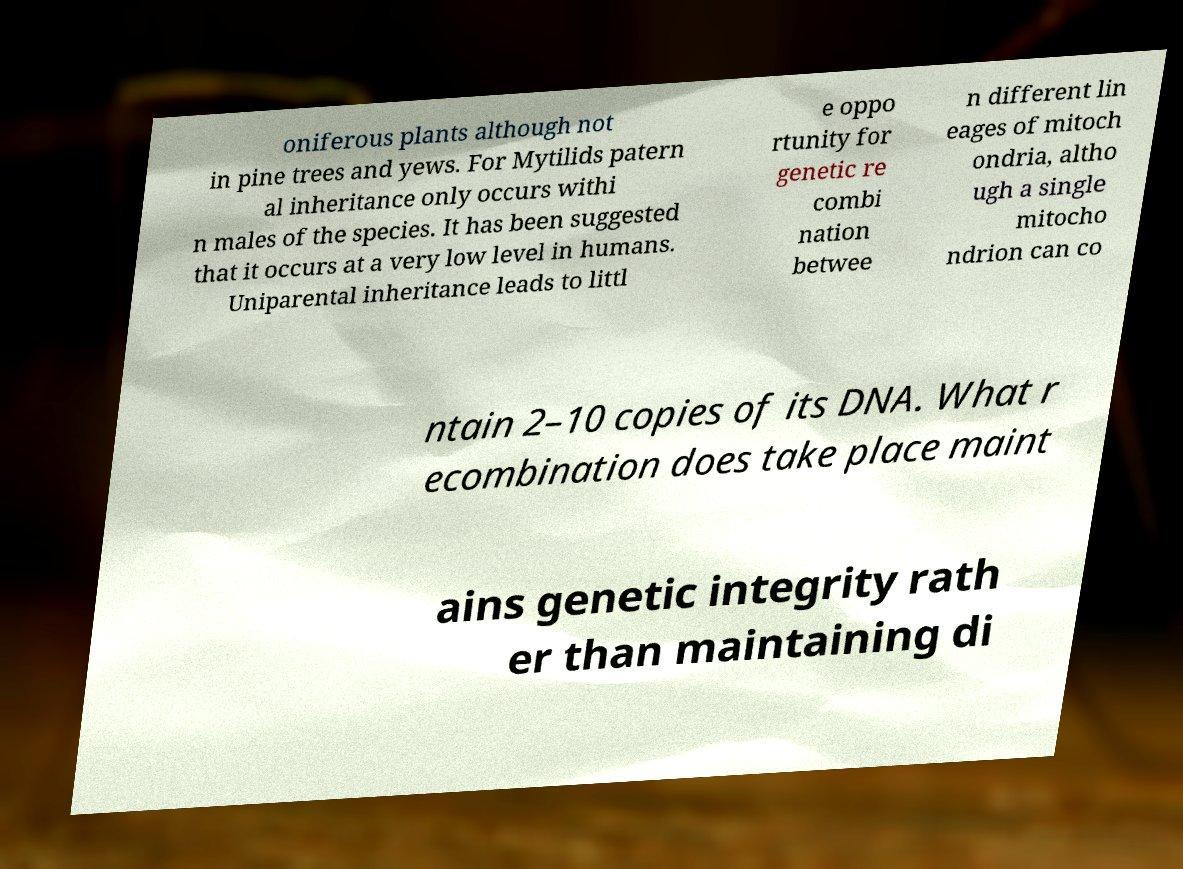What messages or text are displayed in this image? I need them in a readable, typed format. oniferous plants although not in pine trees and yews. For Mytilids patern al inheritance only occurs withi n males of the species. It has been suggested that it occurs at a very low level in humans. Uniparental inheritance leads to littl e oppo rtunity for genetic re combi nation betwee n different lin eages of mitoch ondria, altho ugh a single mitocho ndrion can co ntain 2–10 copies of its DNA. What r ecombination does take place maint ains genetic integrity rath er than maintaining di 